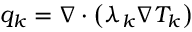Convert formula to latex. <formula><loc_0><loc_0><loc_500><loc_500>q _ { k } = \nabla \cdot \left ( \lambda _ { k } \nabla T _ { k } \right )</formula> 